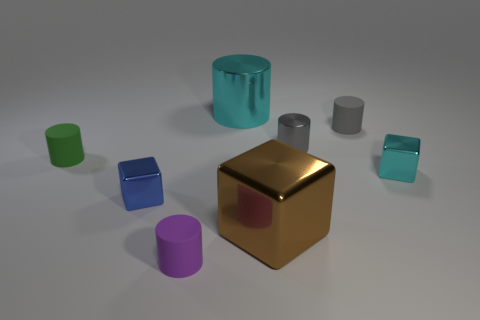Subtract all gray cylinders. How many were subtracted if there are1gray cylinders left? 1 Subtract all brown cylinders. Subtract all blue spheres. How many cylinders are left? 5 Add 2 big green shiny cylinders. How many objects exist? 10 Subtract all cubes. How many objects are left? 5 Add 4 tiny blue blocks. How many tiny blue blocks exist? 5 Subtract 0 purple cubes. How many objects are left? 8 Subtract all brown objects. Subtract all brown things. How many objects are left? 6 Add 3 small cyan things. How many small cyan things are left? 4 